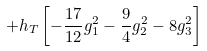Convert formula to latex. <formula><loc_0><loc_0><loc_500><loc_500>+ h _ { T } \left [ - \frac { 1 7 } { 1 2 } g _ { 1 } ^ { 2 } - \frac { 9 } { 4 } g _ { 2 } ^ { 2 } - 8 g _ { 3 } ^ { 2 } \right ]</formula> 